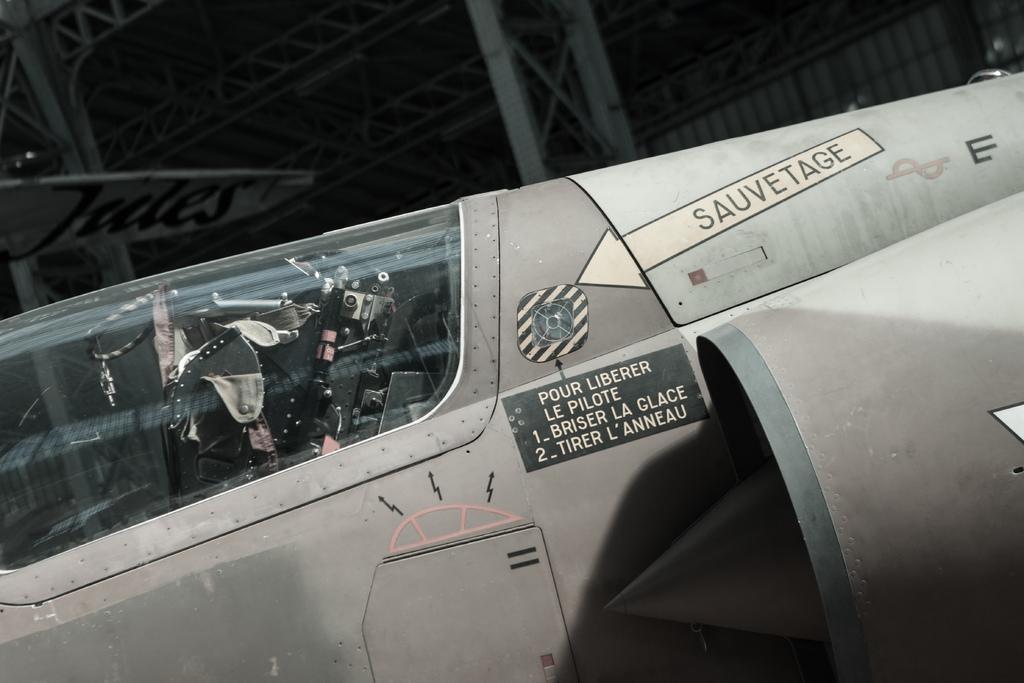Could you give a brief overview of what you see in this image? This picture contains an airplane which is grey in color. We see some text written on the airplane. Behind that, we see a pillar and it is dark in the background. 